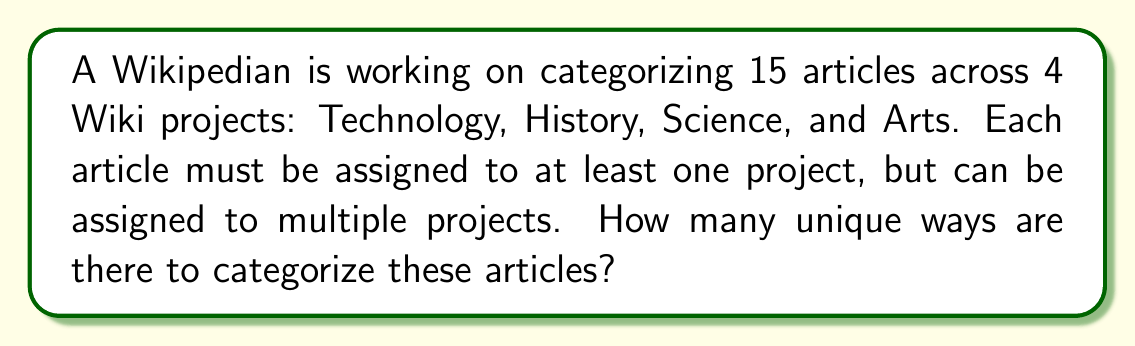Teach me how to tackle this problem. Let's approach this step-by-step:

1) For each article, we have two choices for each project: either it's assigned to that project or it's not. This gives us 2 possibilities for each project.

2) Since there are 4 projects, and each article must be assigned to at least one project, we have $2^4 - 1 = 15$ possible categorization options for each article. We subtract 1 because the article can't be assigned to no projects.

3) Now, we need to make this choice for each of the 15 articles independently.

4) This is a case of independent events, where we make 15 independent choices, each with 15 options.

5) In combinatorics, when we have n independent events, each with k possible outcomes, the total number of possible outcomes is $k^n$.

6) In this case, we have 15 independent events (articles), each with 15 possible outcomes (categorization options).

7) Therefore, the total number of unique ways to categorize the articles is:

   $$15^{15}$$

This is a very large number, approximately $4.38 \times 10^{17}$.
Answer: $15^{15}$ 